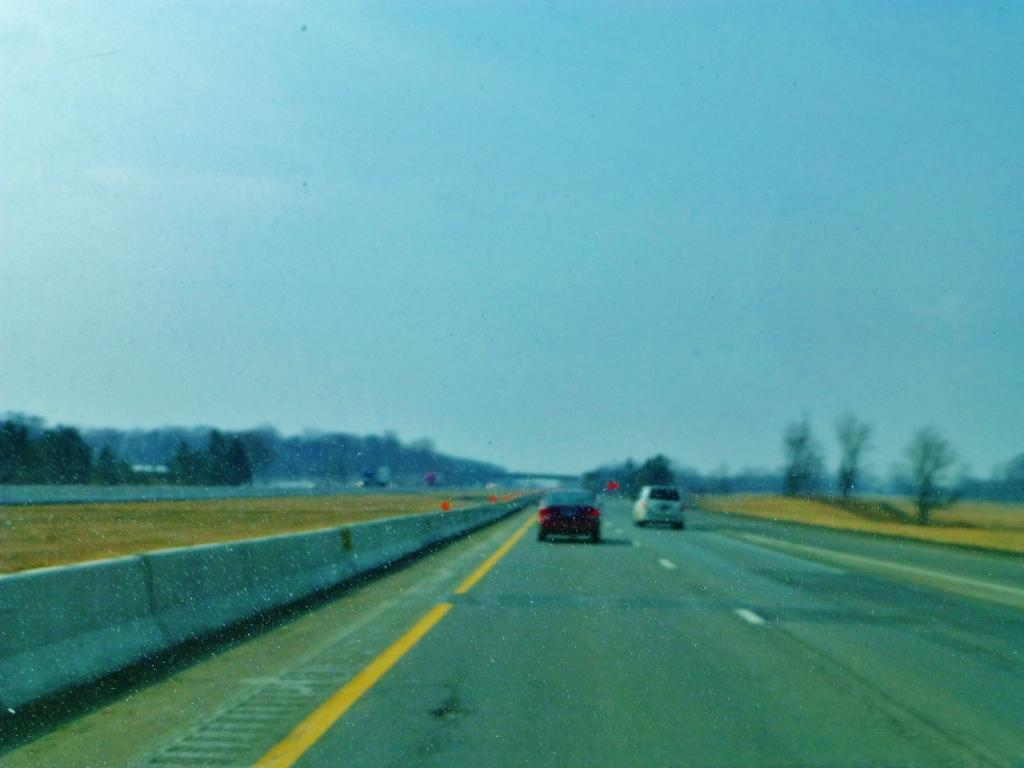What can be seen on the road in the image? There are vehicles on the road in the image. What type of vegetation is present in the image? There are trees and grass in the image. What separates the lanes of traffic on the road? There is a road divider in the image. What type of structure is present over the road in the image? There is a bridge in the image. What is visible in the background of the image? The sky is visible in the background of the image. Can you see any blood on the road in the image? No, there is no blood visible on the road in the image. What type of action is taking place on the bridge in the image? There is no specific action taking place on the bridge in the image; it is simply a structure over the road. 